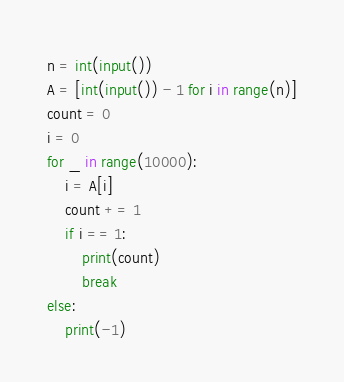Convert code to text. <code><loc_0><loc_0><loc_500><loc_500><_Python_>n = int(input())
A = [int(input()) - 1 for i in range(n)]
count = 0
i = 0
for _ in range(10000):
	i = A[i]
	count += 1
	if i == 1:
		print(count)
		break
else:
	print(-1)</code> 